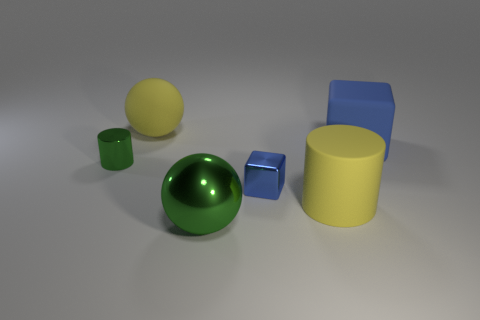Subtract all cyan cylinders. Subtract all yellow cubes. How many cylinders are left? 2 Add 3 large shiny things. How many objects exist? 9 Subtract all cubes. How many objects are left? 4 Add 4 cylinders. How many cylinders exist? 6 Subtract 1 yellow spheres. How many objects are left? 5 Subtract all blue things. Subtract all large gray blocks. How many objects are left? 4 Add 5 blue rubber cubes. How many blue rubber cubes are left? 6 